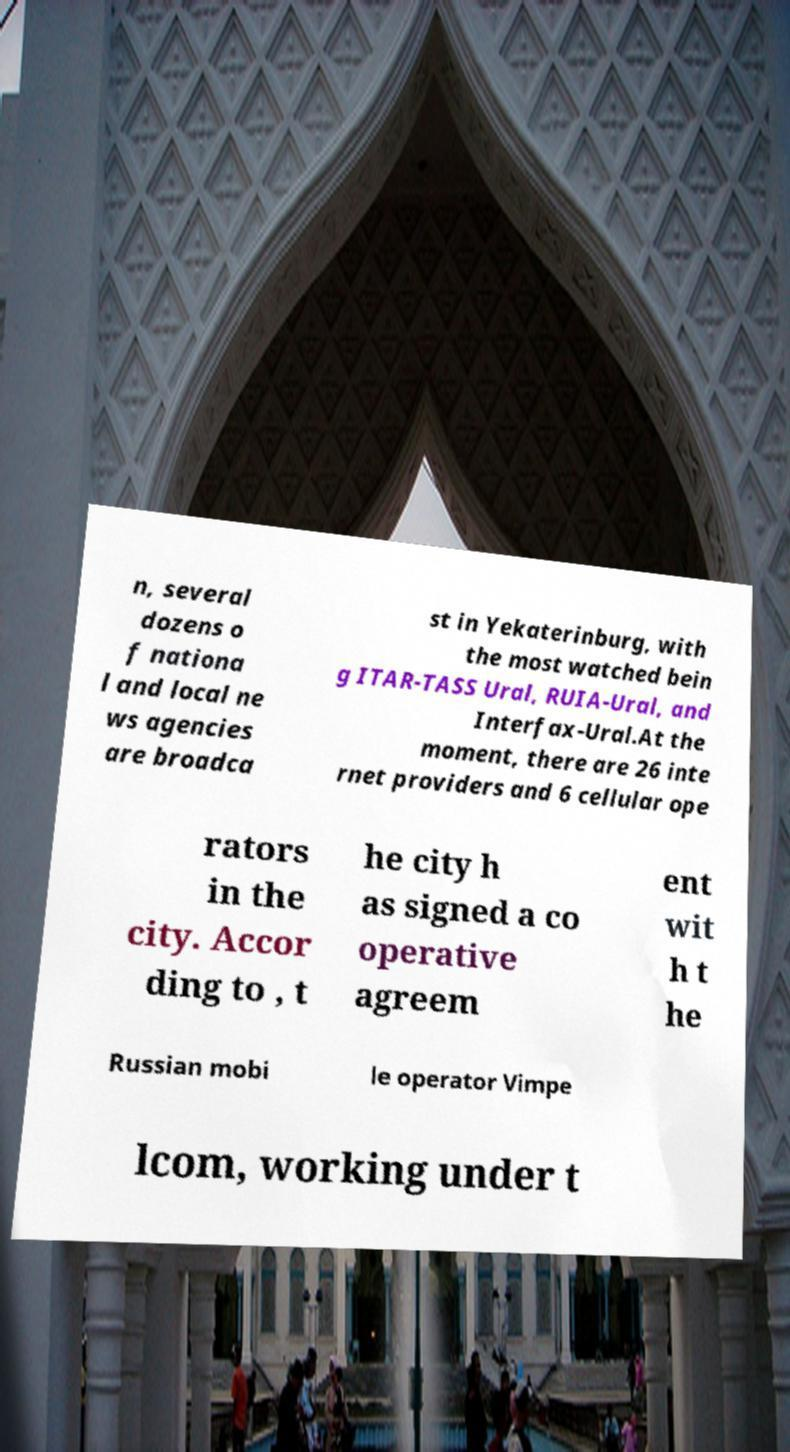I need the written content from this picture converted into text. Can you do that? n, several dozens o f nationa l and local ne ws agencies are broadca st in Yekaterinburg, with the most watched bein g ITAR-TASS Ural, RUIA-Ural, and Interfax-Ural.At the moment, there are 26 inte rnet providers and 6 cellular ope rators in the city. Accor ding to , t he city h as signed a co operative agreem ent wit h t he Russian mobi le operator Vimpe lcom, working under t 